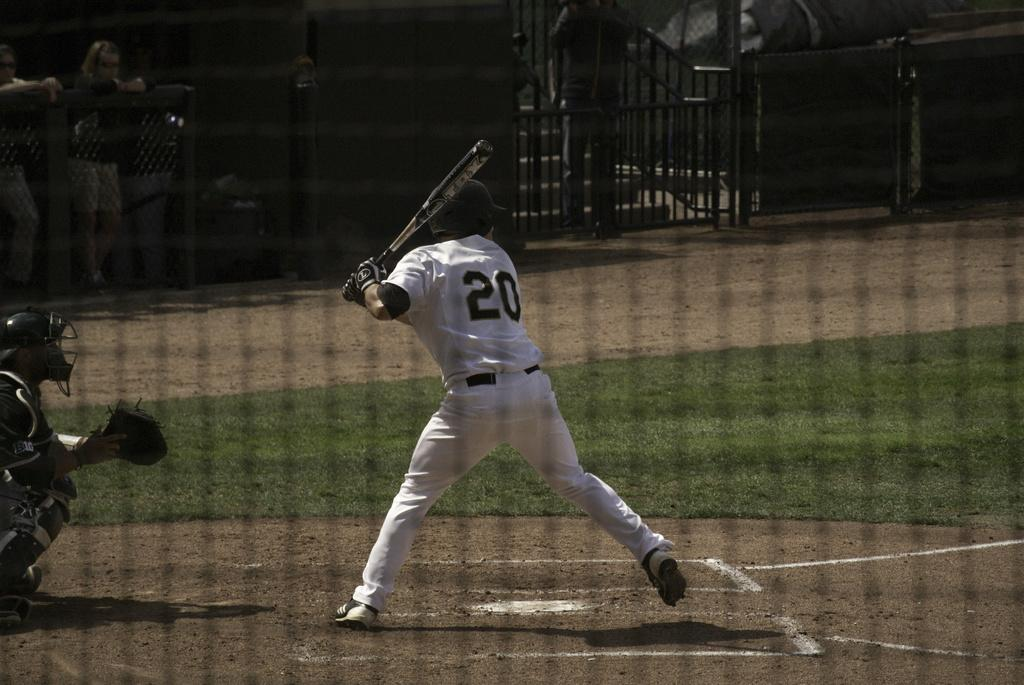<image>
Present a compact description of the photo's key features. Player number 20 is up at bat on the ball field. 